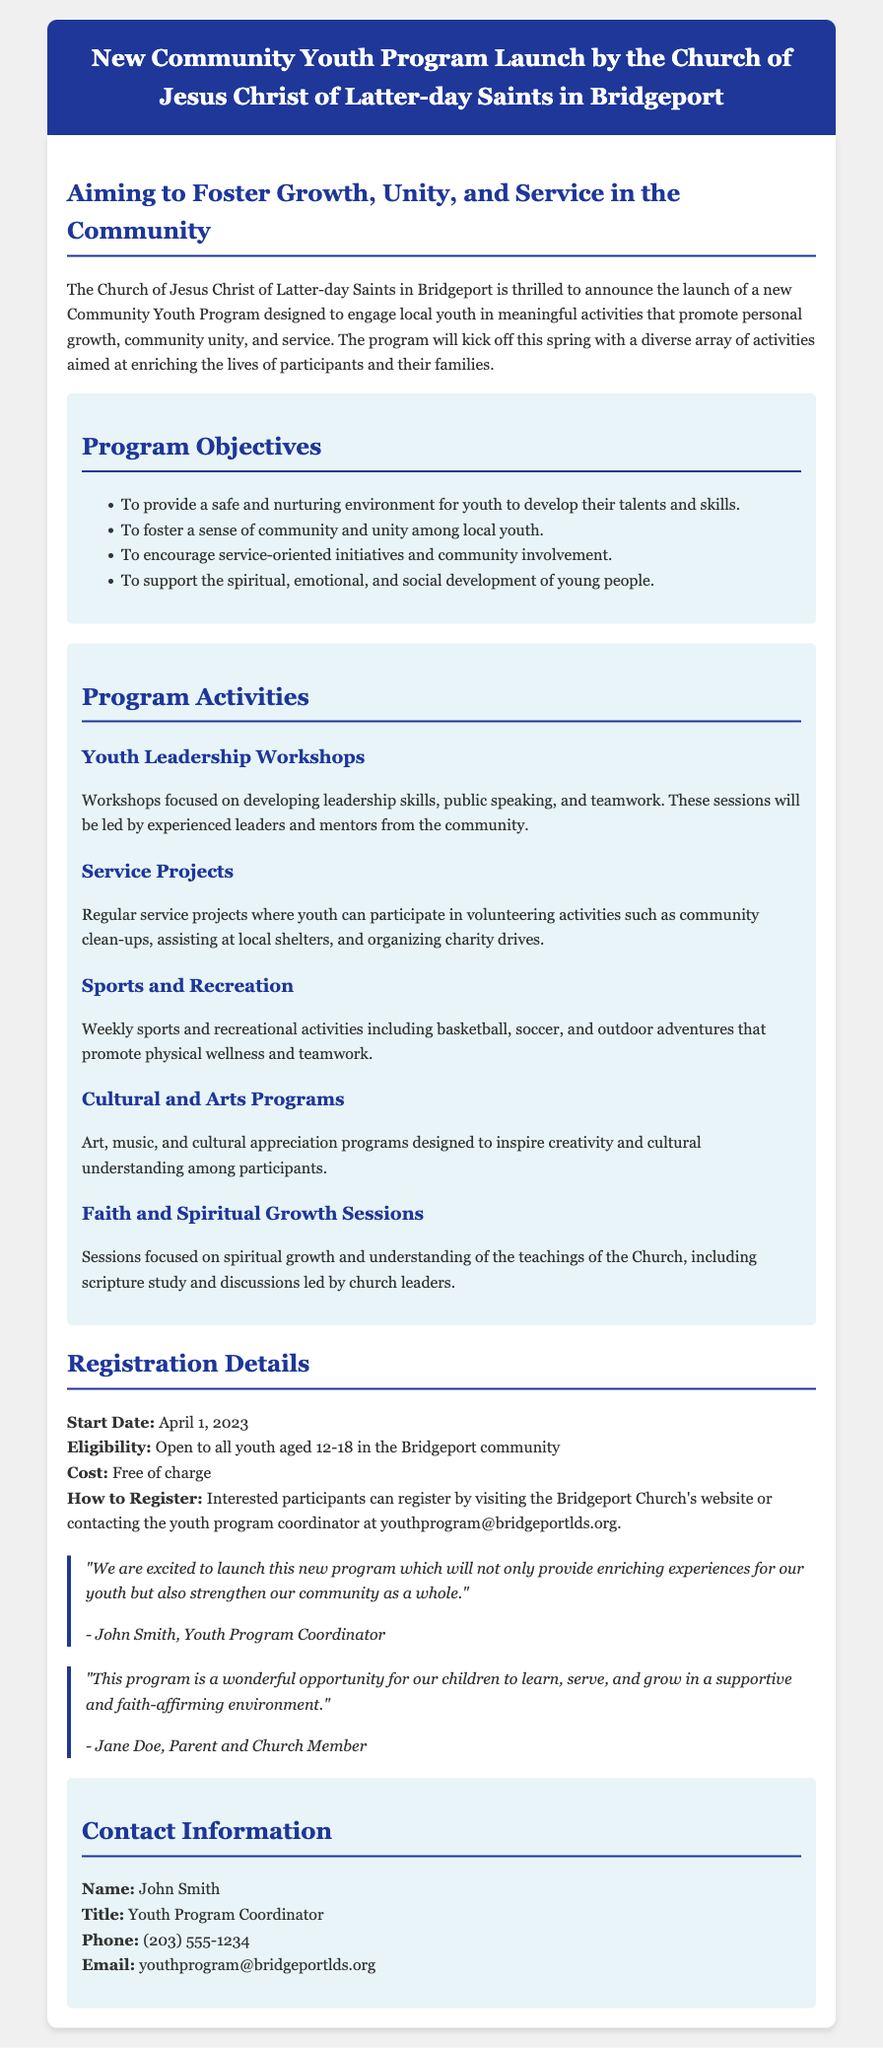What is the start date of the program? The start date of the program is mentioned in the registration details section.
Answer: April 1, 2023 Who is the Youth Program Coordinator? The Youth Program Coordinator's name is stated in the contact information section.
Answer: John Smith What is the age eligibility for the program? The eligibility for the program specifies the age range for participants.
Answer: 12-18 What types of activities are included in the program? The activities section lists various activities designed for the youth.
Answer: Youth Leadership Workshops, Service Projects, Sports and Recreation, Cultural and Arts Programs, Faith and Spiritual Growth Sessions Is there a cost to register for the program? The registration details clarify whether participants need to pay to join the program.
Answer: Free of charge What is one objective of the program? The document outlines several objectives, one of which can be highlighted.
Answer: To provide a safe and nurturing environment How can participants register for the program? The registration details explain how interested youth can enroll.
Answer: Visiting the Bridgeport Church's website or contacting the youth program coordinator What kind of community service projects will participants engage in? The activities section mentions the types of service projects youth will be involved in.
Answer: Community clean-ups, assisting at local shelters, organizing charity drives 